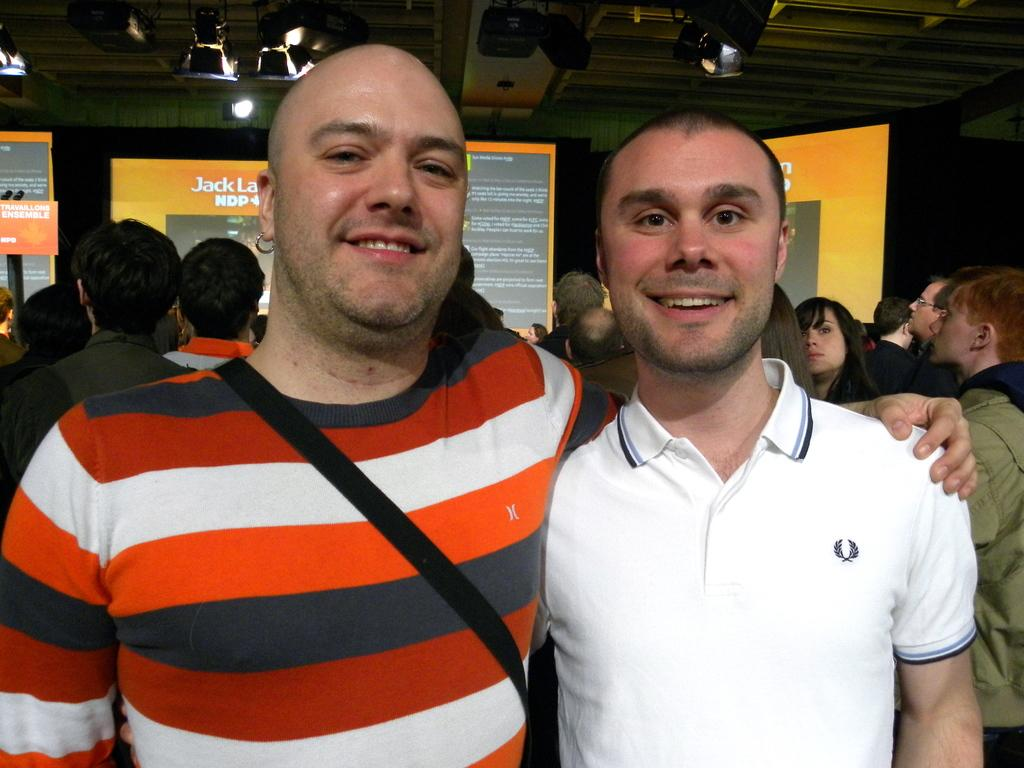Provide a one-sentence caption for the provided image. Two young men one in a striped shirt and the other in a white polo stand in front of many people and a screen with Jack on it,. 